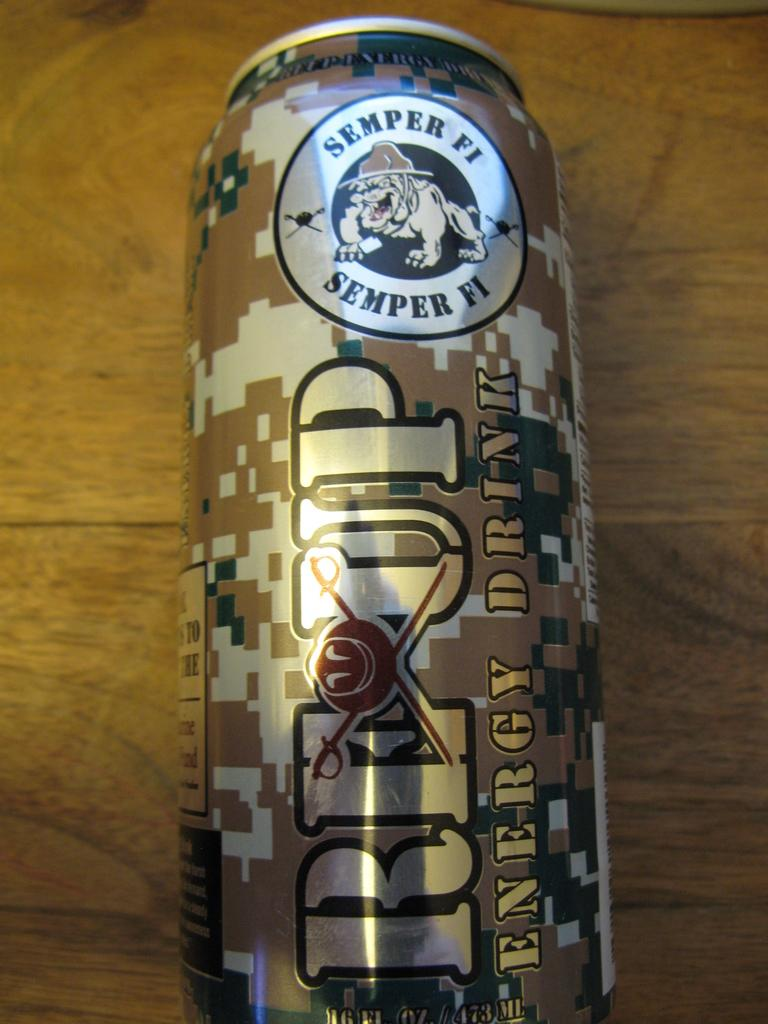<image>
Create a compact narrative representing the image presented. the word semper which is on a can 